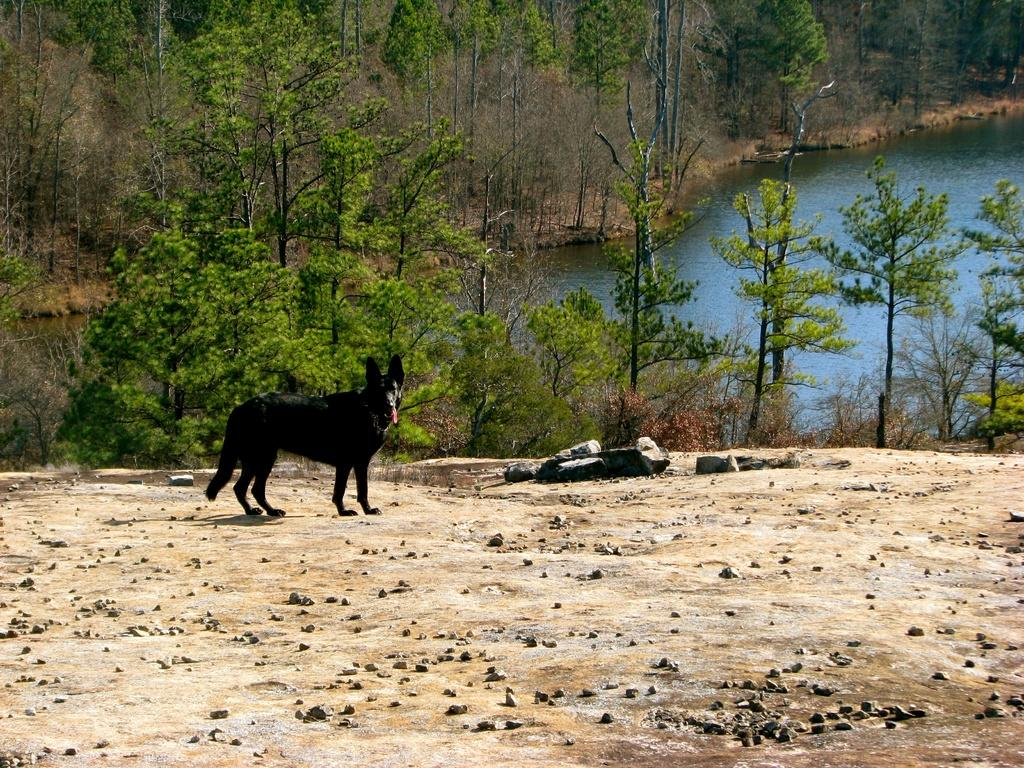What type of animal is in the image? There is a dog in the image. What color is the dog? The dog is black in color. What can be seen on the ground in the image? There are stones on the ground in the image. What is visible in the background of the image? There are trees in the background of the image. What else can be seen in the image besides the dog and trees? There is water visible in the image. How many bulbs are hanging from the trees in the image? There are no bulbs present in the image; it features a dog, stones, trees, and water. What type of chicken can be seen in the image? There are no chickens present in the image; it features a dog, stones, trees, and water. 